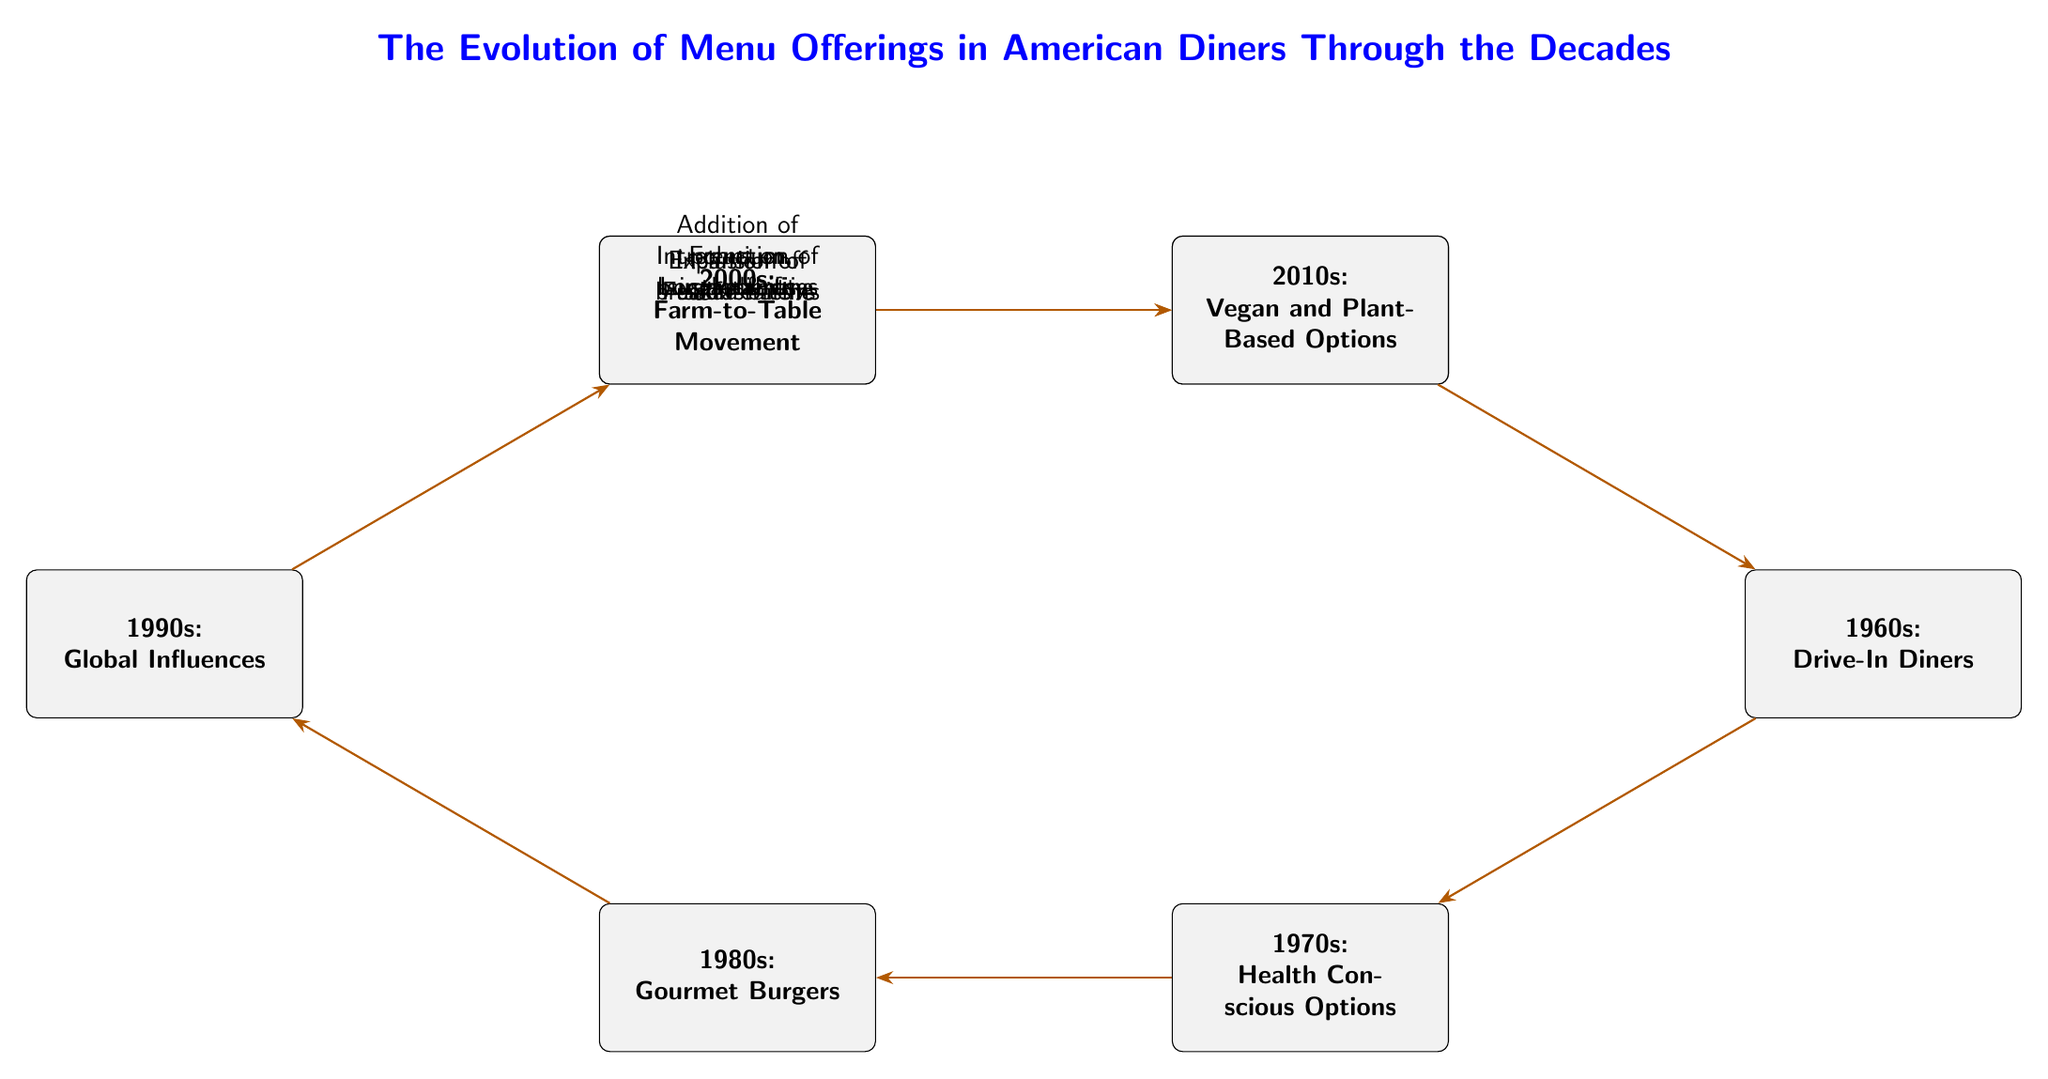What decade introduced burgers and fries to diner menus? The diagram indicates that the transition from the 1940s to the 1950s included the introduction of burgers and fries to diner menus. Therefore, the answer is based on the node representing the 1940s.
Answer: 1940s Which decade is associated with the rise of gourmet burgers? According to the diagram, gourmet burgers are specifically categorized under the 1980s, as indicated by the corresponding node and the absence of references to gourmet burgers in other decades.
Answer: 1980s What was a significant addition to diner menus in the 1960s? The diagram shows that the 1960s decade marked the transition to including salad bars on diner menus, making it a noteworthy addition for that time period.
Answer: Inclusion of salad bars How many decades are represented in this diagram? The diagram contains eight nodes, each signifying a decade of menu offerings in diners, hence the total number of represented decades can be counted directly from these nodes.
Answer: 8 What transition connects the 1990s to the 2000s? There is a clear directional transition from the 1990s to the 2000s in the diagram, specifically denoting that the focus on local sourcing occurred in this timeframe, linking the two decades' menu evolutions.
Answer: Local sourcing What menu trend started in the 2010s? The diagram identifies the 2010s specifically with a focus on vegan and plant-based options being introduced to diner menus, marking this as a defining trend for that decade.
Answer: Vegan and Plant-Based Options What does the transition from 1980s to 1990s signify? The diagram illustrates that the transition from the 1980s to the 1990s is characterized by the introduction of fusion cuisine, highlighting the culinary influence and diversity that began to appear during that time in diners.
Answer: Fusion cuisine What was emphasized in the 2000s regarding menu offerings? The diagram states that during the 2000s, there was a strong emphasis on sustainability within menu offerings, connecting this decade's focus to broader societal trends regarding food sourcing and environmental impact.
Answer: Focus on sustainability What is the overarching title of the diagram? The title of the diagram is prominently displayed at the top and states the subject matter it covers which is related to the evolution of menu offerings in American diners over multiple decades.
Answer: The Evolution of Menu Offerings in American Diners Through the Decades 